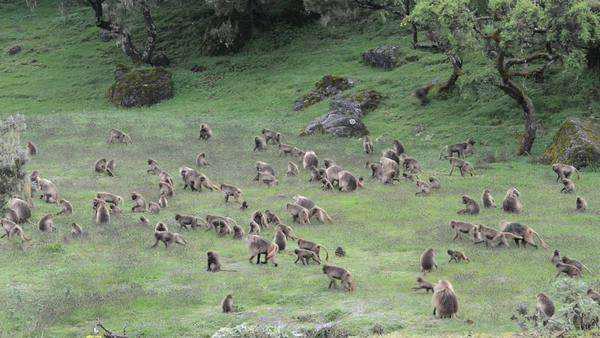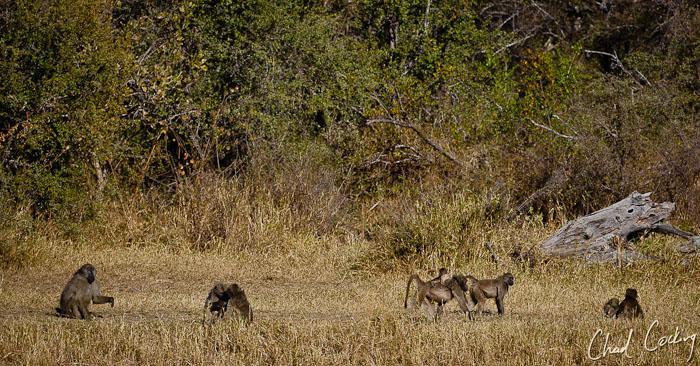The first image is the image on the left, the second image is the image on the right. Assess this claim about the two images: "The left image contains no more than four baboons and does not contain any baby baboons.". Correct or not? Answer yes or no. No. The first image is the image on the left, the second image is the image on the right. For the images shown, is this caption "There are seven lesser apes in the image to the right." true? Answer yes or no. Yes. The first image is the image on the left, the second image is the image on the right. Considering the images on both sides, is "There are less than ten monkeys in the image on the right." valid? Answer yes or no. Yes. 